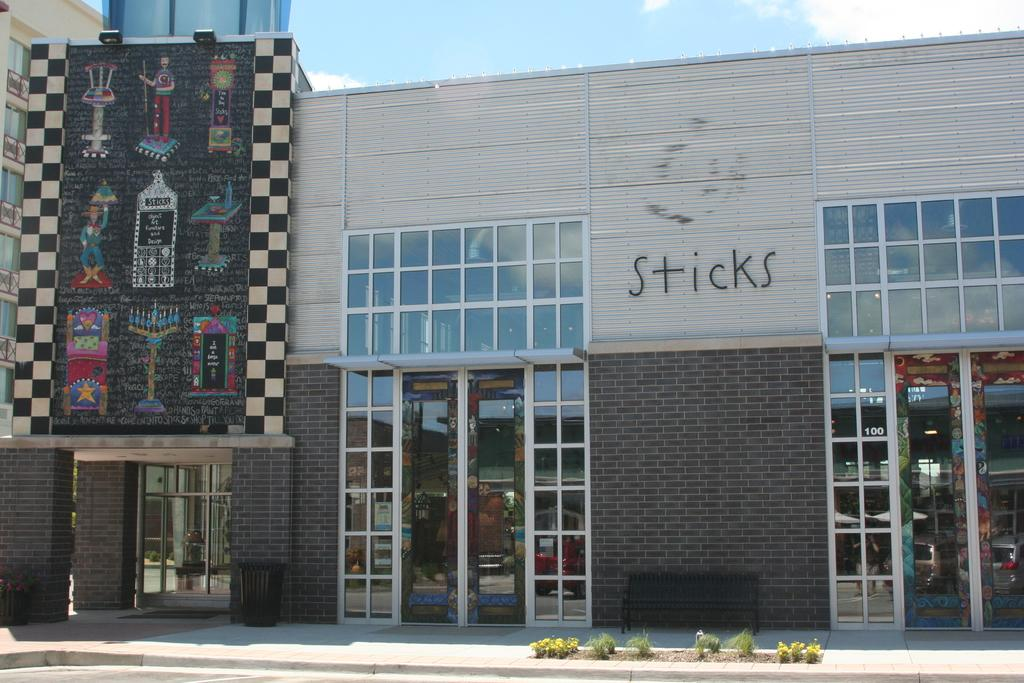<image>
Give a short and clear explanation of the subsequent image. A building with a colorful mural outside named Sticks 